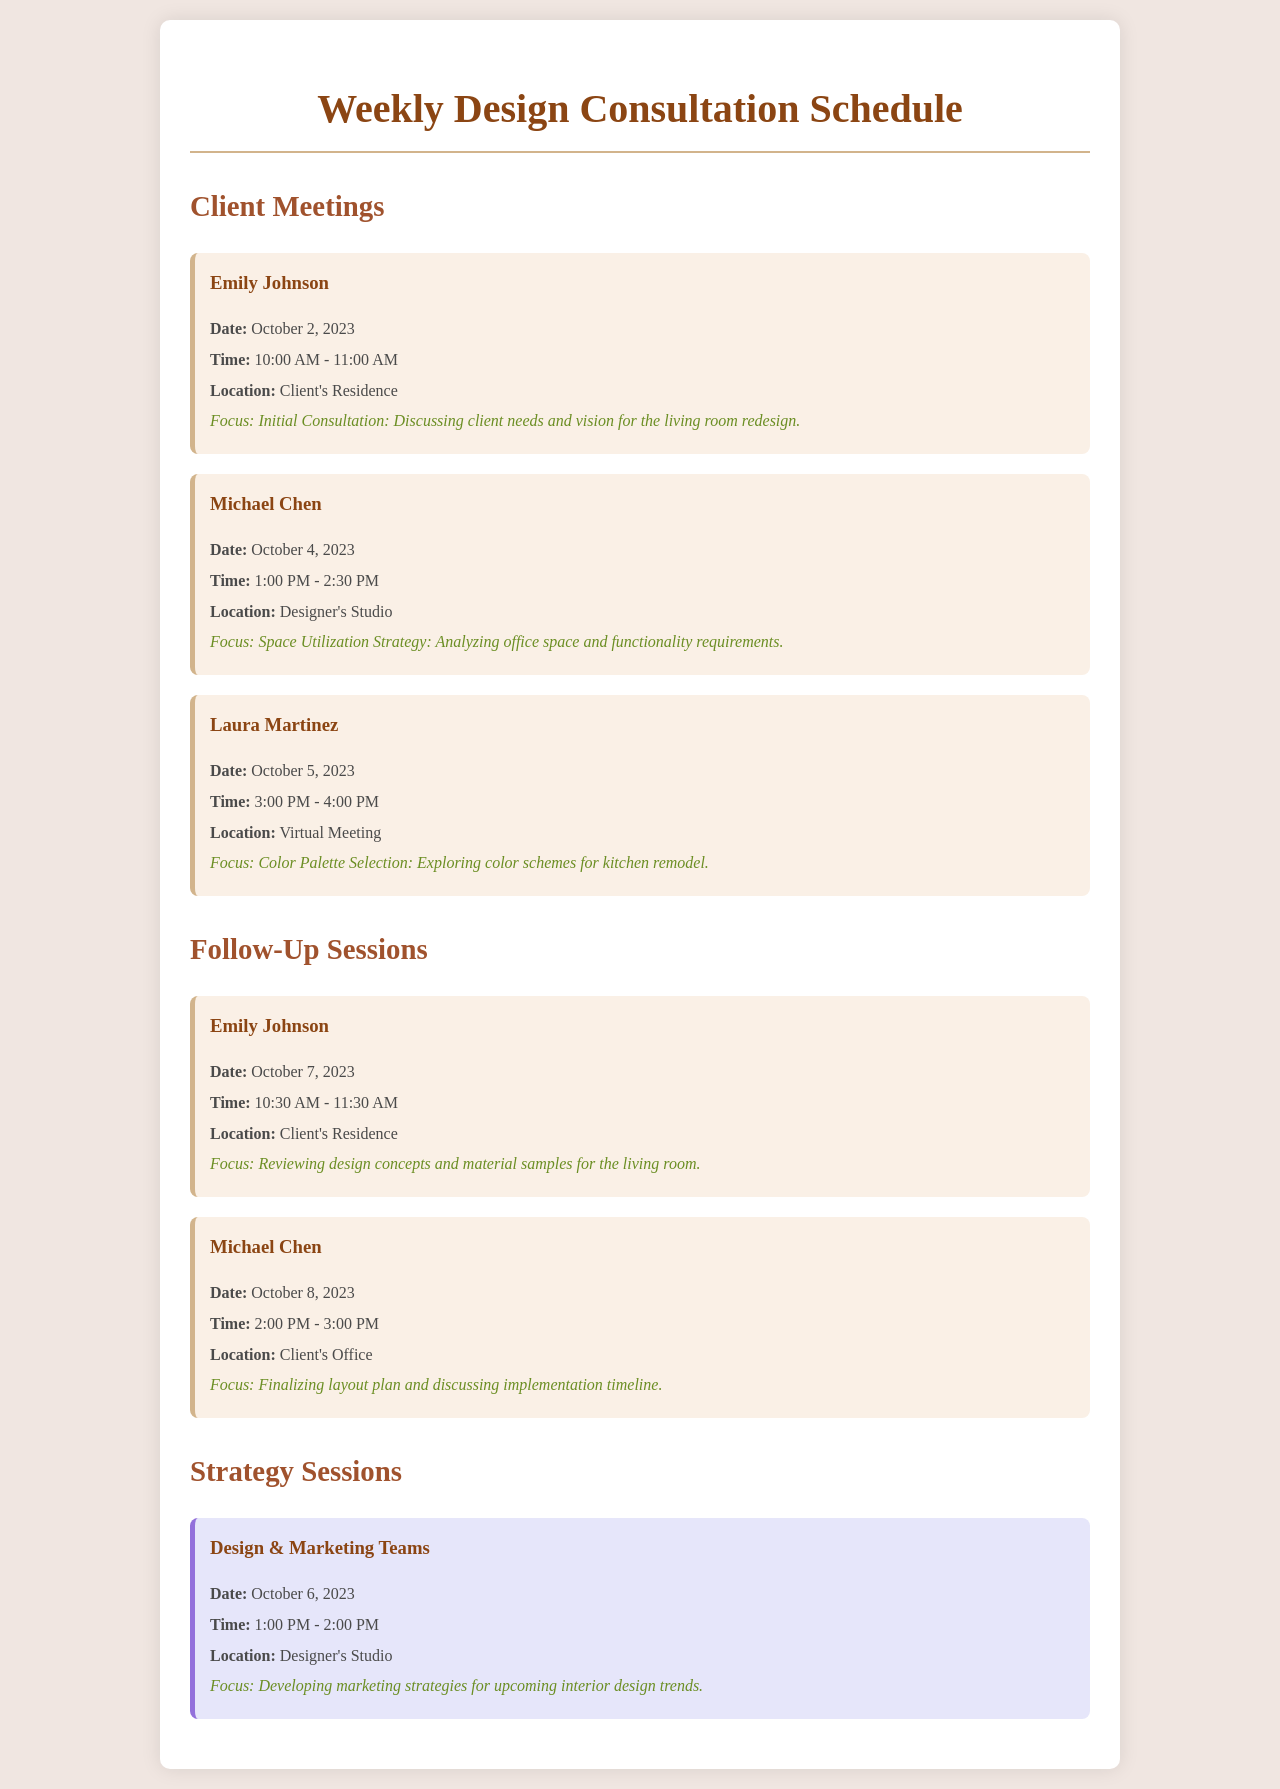What is the date of Emily Johnson's initial consultation? The date is specified in the schedule item for Emily Johnson's initial consultation as October 2, 2023.
Answer: October 2, 2023 What time is Michael Chen's space utilization strategy meeting? The meeting time for Michael Chen is listed as 1:00 PM - 2:30 PM in the document.
Answer: 1:00 PM - 2:30 PM Where is Laura Martinez's color palette selection meeting held? The location for Laura Martinez's meeting is indicated as a Virtual Meeting in the document.
Answer: Virtual Meeting What is the focus of the strategy session on October 6, 2023? The focus of the strategy session is described as developing marketing strategies for upcoming interior design trends.
Answer: Developing marketing strategies for upcoming interior design trends How many follow-up sessions are scheduled for Emily Johnson? The document specifies two follow-up sessions scheduled for Emily Johnson.
Answer: Two What color is used for the background of the strategy session item? The document states that the strategy session item has a background color of light purple (e6e6fa).
Answer: Light purple What date is set for the finalizing layout plan meeting with Michael Chen? The date for the meeting with Michael Chen to finalize the layout plan is mentioned as October 8, 2023.
Answer: October 8, 2023 What is the purpose of the follow-up session with Michael Chen on October 8, 2023? The purpose is to finalize the layout plan and discuss the implementation timeline.
Answer: Finalizing layout plan and discussing implementation timeline What is the overall title of this document? The title is clearly stated as "Weekly Design Consultation Schedule" at the top of the document.
Answer: Weekly Design Consultation Schedule 